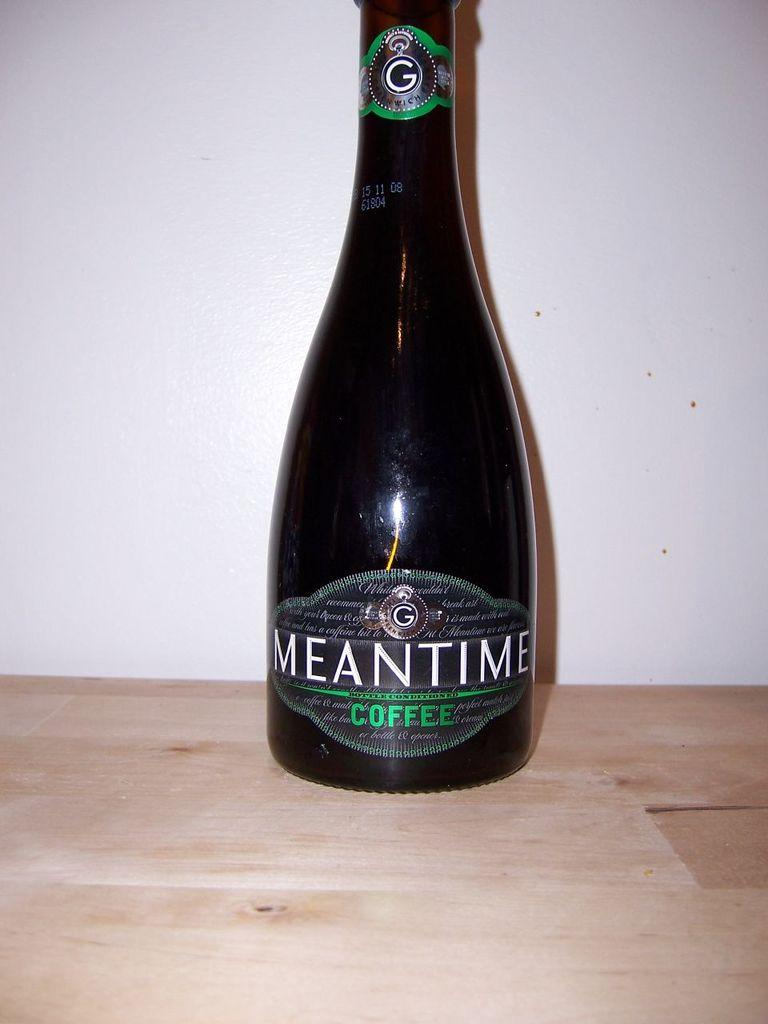<image>
Create a compact narrative representing the image presented. A dark colored glass bottle of Meantime bottle conditioned coffee with green and white text on the black label. 